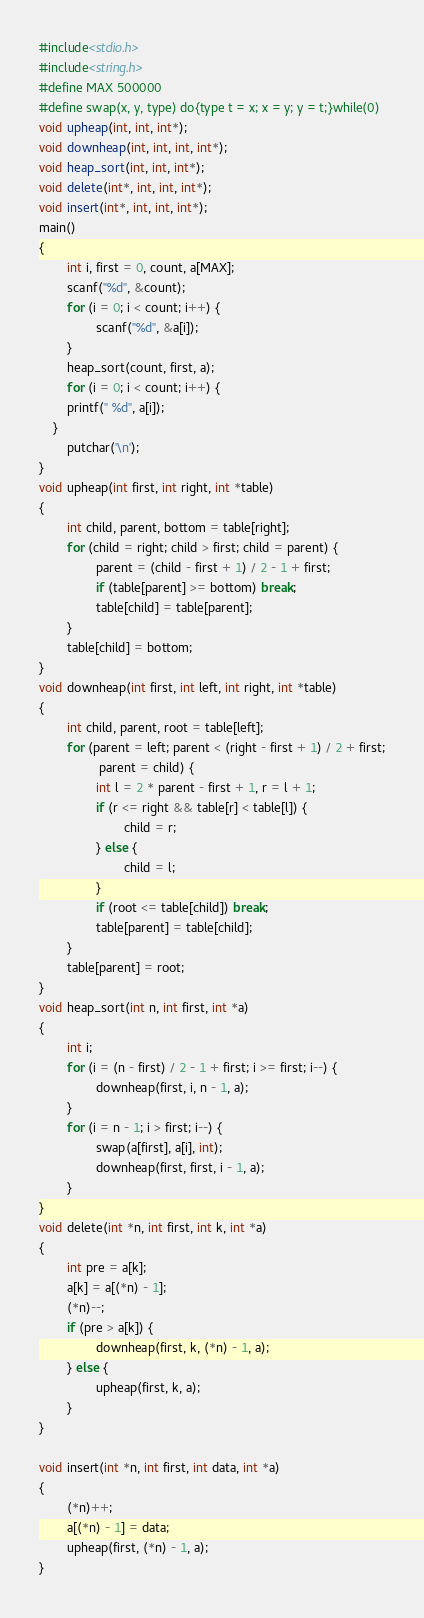<code> <loc_0><loc_0><loc_500><loc_500><_C_>#include<stdio.h>
#include<string.h>
#define MAX 500000
#define swap(x, y, type) do{type t = x; x = y; y = t;}while(0)
void upheap(int, int, int*);
void downheap(int, int, int, int*);
void heap_sort(int, int, int*);
void delete(int*, int, int, int*);
void insert(int*, int, int, int*);
main()
{
        int i, first = 0, count, a[MAX];
        scanf("%d", &count);
        for (i = 0; i < count; i++) {
                scanf("%d", &a[i]);
        }
        heap_sort(count, first, a);
        for (i = 0; i < count; i++) {
        printf(" %d", a[i]);
    }
        putchar('\n');
}
void upheap(int first, int right, int *table)
{
        int child, parent, bottom = table[right];
        for (child = right; child > first; child = parent) {
                parent = (child - first + 1) / 2 - 1 + first;
                if (table[parent] >= bottom) break;
                table[child] = table[parent];
        }
        table[child] = bottom;
}
void downheap(int first, int left, int right, int *table)
{
        int child, parent, root = table[left];
        for (parent = left; parent < (right - first + 1) / 2 + first;
                 parent = child) {
                int l = 2 * parent - first + 1, r = l + 1;
                if (r <= right && table[r] < table[l]) {
                        child = r;
                } else {
                        child = l;
                }
                if (root <= table[child]) break;
                table[parent] = table[child];
        }
        table[parent] = root;
}
void heap_sort(int n, int first, int *a)
{
        int i;
        for (i = (n - first) / 2 - 1 + first; i >= first; i--) {
                downheap(first, i, n - 1, a);
        }
        for (i = n - 1; i > first; i--) {
                swap(a[first], a[i], int);
                downheap(first, first, i - 1, a);
        }
}
void delete(int *n, int first, int k, int *a)
{
        int pre = a[k];
        a[k] = a[(*n) - 1];
        (*n)--;
        if (pre > a[k]) {
                downheap(first, k, (*n) - 1, a);
        } else {
                upheap(first, k, a);
        }
}

void insert(int *n, int first, int data, int *a)
{
        (*n)++;
        a[(*n) - 1] = data;
        upheap(first, (*n) - 1, a);
}
</code> 